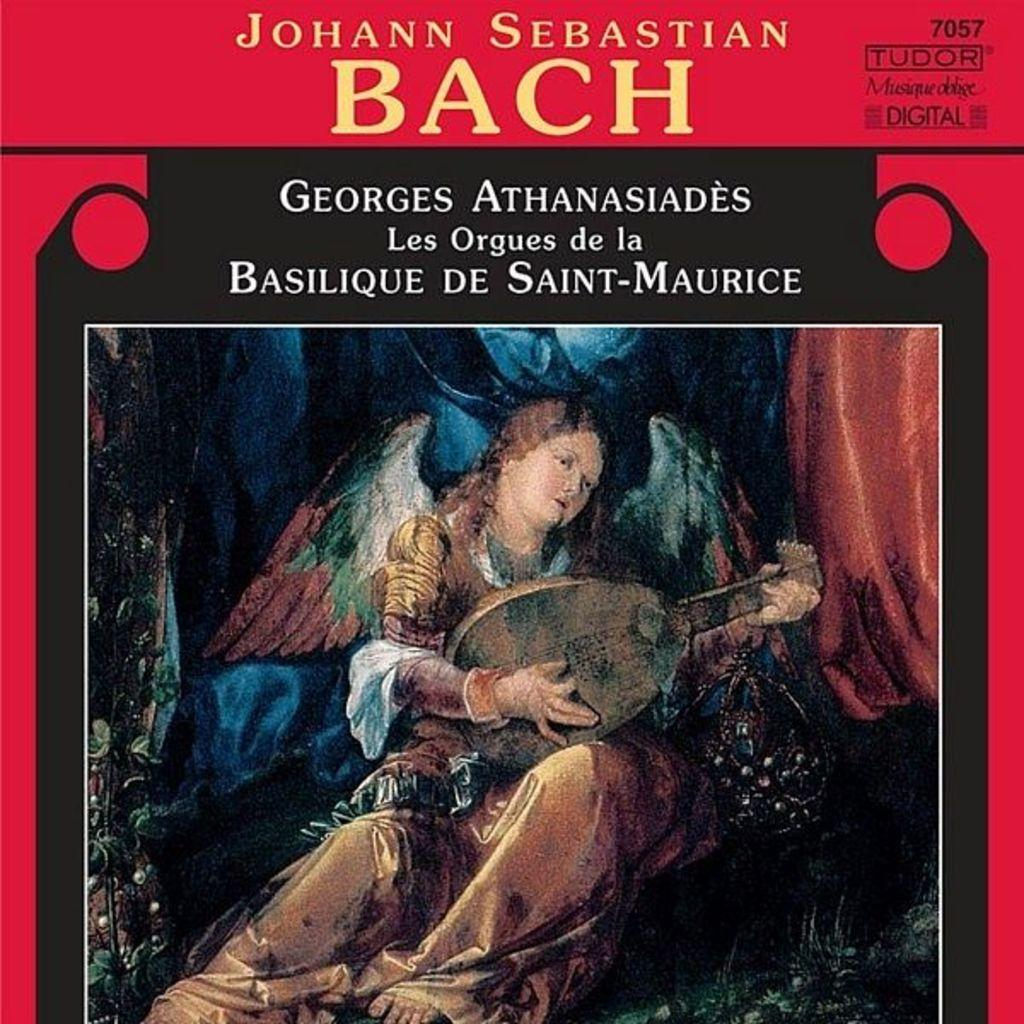<image>
Share a concise interpretation of the image provided. an album that was made by the musician Baach 